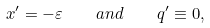Convert formula to latex. <formula><loc_0><loc_0><loc_500><loc_500>x ^ { \prime } = - \varepsilon \quad a n d \quad q ^ { \prime } \equiv 0 ,</formula> 